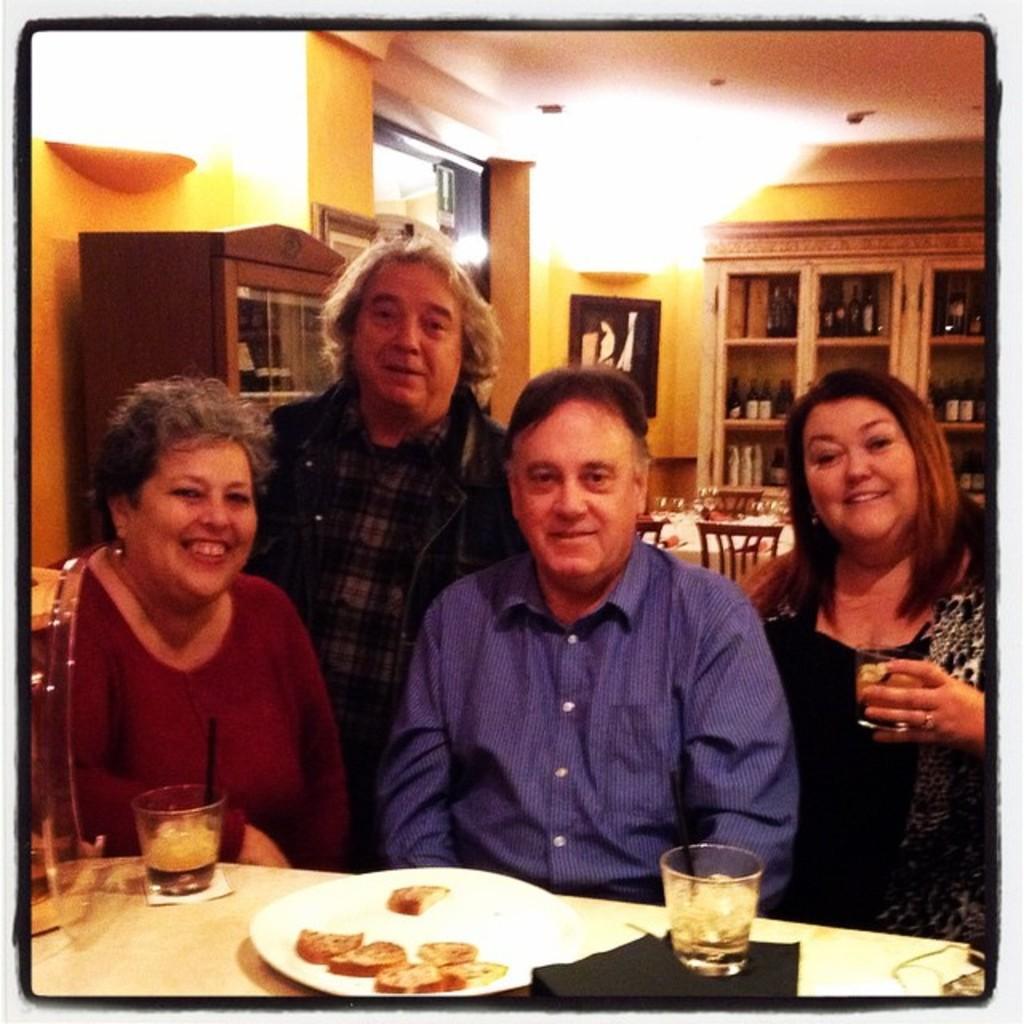Describe this image in one or two sentences. In this picture we can see four people they are all seated on the chair and one person is standing, in front of them we can find couple of glasses and a plate on the table, in a background we can see couple of bottles in the racks, wall frames and couple of lights. 